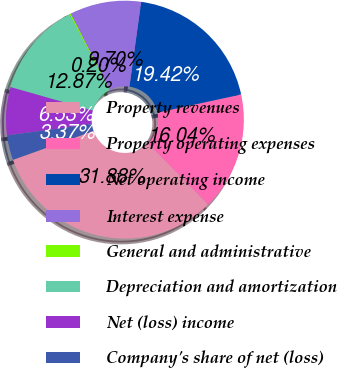Convert chart to OTSL. <chart><loc_0><loc_0><loc_500><loc_500><pie_chart><fcel>Property revenues<fcel>Property operating expenses<fcel>Net operating income<fcel>Interest expense<fcel>General and administrative<fcel>Depreciation and amortization<fcel>Net (loss) income<fcel>Company's share of net (loss)<nl><fcel>31.88%<fcel>16.04%<fcel>19.42%<fcel>9.7%<fcel>0.2%<fcel>12.87%<fcel>6.53%<fcel>3.37%<nl></chart> 